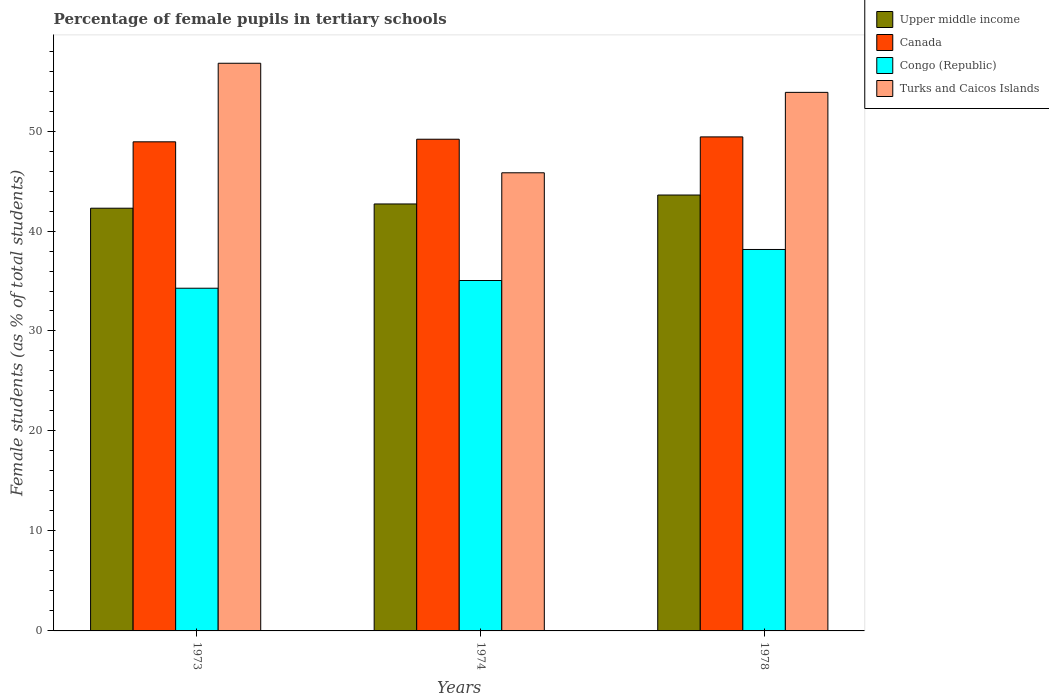How many different coloured bars are there?
Your response must be concise. 4. How many groups of bars are there?
Offer a terse response. 3. Are the number of bars on each tick of the X-axis equal?
Your response must be concise. Yes. How many bars are there on the 1st tick from the left?
Your answer should be very brief. 4. How many bars are there on the 3rd tick from the right?
Make the answer very short. 4. What is the label of the 1st group of bars from the left?
Provide a short and direct response. 1973. In how many cases, is the number of bars for a given year not equal to the number of legend labels?
Your answer should be very brief. 0. What is the percentage of female pupils in tertiary schools in Canada in 1978?
Make the answer very short. 49.41. Across all years, what is the maximum percentage of female pupils in tertiary schools in Congo (Republic)?
Give a very brief answer. 38.15. Across all years, what is the minimum percentage of female pupils in tertiary schools in Congo (Republic)?
Your answer should be compact. 34.28. In which year was the percentage of female pupils in tertiary schools in Congo (Republic) maximum?
Your answer should be compact. 1978. In which year was the percentage of female pupils in tertiary schools in Congo (Republic) minimum?
Offer a terse response. 1973. What is the total percentage of female pupils in tertiary schools in Congo (Republic) in the graph?
Provide a succinct answer. 107.48. What is the difference between the percentage of female pupils in tertiary schools in Canada in 1973 and that in 1978?
Your answer should be compact. -0.49. What is the difference between the percentage of female pupils in tertiary schools in Congo (Republic) in 1973 and the percentage of female pupils in tertiary schools in Turks and Caicos Islands in 1978?
Make the answer very short. -19.59. What is the average percentage of female pupils in tertiary schools in Turks and Caicos Islands per year?
Keep it short and to the point. 52.16. In the year 1973, what is the difference between the percentage of female pupils in tertiary schools in Upper middle income and percentage of female pupils in tertiary schools in Congo (Republic)?
Your response must be concise. 8. What is the ratio of the percentage of female pupils in tertiary schools in Turks and Caicos Islands in 1973 to that in 1978?
Offer a terse response. 1.05. What is the difference between the highest and the second highest percentage of female pupils in tertiary schools in Upper middle income?
Keep it short and to the point. 0.89. What is the difference between the highest and the lowest percentage of female pupils in tertiary schools in Turks and Caicos Islands?
Provide a short and direct response. 10.96. In how many years, is the percentage of female pupils in tertiary schools in Congo (Republic) greater than the average percentage of female pupils in tertiary schools in Congo (Republic) taken over all years?
Make the answer very short. 1. What does the 3rd bar from the left in 1973 represents?
Make the answer very short. Congo (Republic). What does the 4th bar from the right in 1978 represents?
Give a very brief answer. Upper middle income. How many bars are there?
Your answer should be compact. 12. Are all the bars in the graph horizontal?
Your response must be concise. No. What is the difference between two consecutive major ticks on the Y-axis?
Your answer should be compact. 10. Does the graph contain grids?
Your answer should be compact. No. What is the title of the graph?
Offer a very short reply. Percentage of female pupils in tertiary schools. What is the label or title of the Y-axis?
Your response must be concise. Female students (as % of total students). What is the Female students (as % of total students) of Upper middle income in 1973?
Ensure brevity in your answer.  42.28. What is the Female students (as % of total students) in Canada in 1973?
Ensure brevity in your answer.  48.92. What is the Female students (as % of total students) in Congo (Republic) in 1973?
Your answer should be very brief. 34.28. What is the Female students (as % of total students) in Turks and Caicos Islands in 1973?
Your answer should be compact. 56.78. What is the Female students (as % of total students) of Upper middle income in 1974?
Offer a terse response. 42.71. What is the Female students (as % of total students) in Canada in 1974?
Provide a succinct answer. 49.18. What is the Female students (as % of total students) of Congo (Republic) in 1974?
Your answer should be very brief. 35.05. What is the Female students (as % of total students) in Turks and Caicos Islands in 1974?
Keep it short and to the point. 45.82. What is the Female students (as % of total students) in Upper middle income in 1978?
Offer a very short reply. 43.6. What is the Female students (as % of total students) in Canada in 1978?
Offer a terse response. 49.41. What is the Female students (as % of total students) of Congo (Republic) in 1978?
Provide a succinct answer. 38.15. What is the Female students (as % of total students) of Turks and Caicos Islands in 1978?
Provide a short and direct response. 53.87. Across all years, what is the maximum Female students (as % of total students) of Upper middle income?
Your response must be concise. 43.6. Across all years, what is the maximum Female students (as % of total students) of Canada?
Give a very brief answer. 49.41. Across all years, what is the maximum Female students (as % of total students) of Congo (Republic)?
Offer a terse response. 38.15. Across all years, what is the maximum Female students (as % of total students) in Turks and Caicos Islands?
Make the answer very short. 56.78. Across all years, what is the minimum Female students (as % of total students) of Upper middle income?
Your response must be concise. 42.28. Across all years, what is the minimum Female students (as % of total students) in Canada?
Give a very brief answer. 48.92. Across all years, what is the minimum Female students (as % of total students) in Congo (Republic)?
Provide a short and direct response. 34.28. Across all years, what is the minimum Female students (as % of total students) of Turks and Caicos Islands?
Your response must be concise. 45.82. What is the total Female students (as % of total students) in Upper middle income in the graph?
Your answer should be compact. 128.59. What is the total Female students (as % of total students) of Canada in the graph?
Offer a very short reply. 147.52. What is the total Female students (as % of total students) of Congo (Republic) in the graph?
Offer a very short reply. 107.48. What is the total Female students (as % of total students) in Turks and Caicos Islands in the graph?
Provide a succinct answer. 156.47. What is the difference between the Female students (as % of total students) of Upper middle income in 1973 and that in 1974?
Make the answer very short. -0.43. What is the difference between the Female students (as % of total students) of Canada in 1973 and that in 1974?
Provide a short and direct response. -0.26. What is the difference between the Female students (as % of total students) in Congo (Republic) in 1973 and that in 1974?
Offer a terse response. -0.77. What is the difference between the Female students (as % of total students) of Turks and Caicos Islands in 1973 and that in 1974?
Give a very brief answer. 10.96. What is the difference between the Female students (as % of total students) of Upper middle income in 1973 and that in 1978?
Provide a succinct answer. -1.32. What is the difference between the Female students (as % of total students) of Canada in 1973 and that in 1978?
Provide a short and direct response. -0.49. What is the difference between the Female students (as % of total students) of Congo (Republic) in 1973 and that in 1978?
Offer a very short reply. -3.88. What is the difference between the Female students (as % of total students) of Turks and Caicos Islands in 1973 and that in 1978?
Provide a succinct answer. 2.91. What is the difference between the Female students (as % of total students) in Upper middle income in 1974 and that in 1978?
Your answer should be compact. -0.89. What is the difference between the Female students (as % of total students) of Canada in 1974 and that in 1978?
Provide a succinct answer. -0.23. What is the difference between the Female students (as % of total students) in Congo (Republic) in 1974 and that in 1978?
Your answer should be compact. -3.1. What is the difference between the Female students (as % of total students) of Turks and Caicos Islands in 1974 and that in 1978?
Provide a succinct answer. -8.04. What is the difference between the Female students (as % of total students) in Upper middle income in 1973 and the Female students (as % of total students) in Canada in 1974?
Your answer should be compact. -6.9. What is the difference between the Female students (as % of total students) in Upper middle income in 1973 and the Female students (as % of total students) in Congo (Republic) in 1974?
Make the answer very short. 7.23. What is the difference between the Female students (as % of total students) in Upper middle income in 1973 and the Female students (as % of total students) in Turks and Caicos Islands in 1974?
Provide a short and direct response. -3.54. What is the difference between the Female students (as % of total students) of Canada in 1973 and the Female students (as % of total students) of Congo (Republic) in 1974?
Your answer should be compact. 13.87. What is the difference between the Female students (as % of total students) of Canada in 1973 and the Female students (as % of total students) of Turks and Caicos Islands in 1974?
Give a very brief answer. 3.1. What is the difference between the Female students (as % of total students) of Congo (Republic) in 1973 and the Female students (as % of total students) of Turks and Caicos Islands in 1974?
Offer a very short reply. -11.55. What is the difference between the Female students (as % of total students) in Upper middle income in 1973 and the Female students (as % of total students) in Canada in 1978?
Give a very brief answer. -7.13. What is the difference between the Female students (as % of total students) of Upper middle income in 1973 and the Female students (as % of total students) of Congo (Republic) in 1978?
Offer a terse response. 4.13. What is the difference between the Female students (as % of total students) in Upper middle income in 1973 and the Female students (as % of total students) in Turks and Caicos Islands in 1978?
Make the answer very short. -11.59. What is the difference between the Female students (as % of total students) in Canada in 1973 and the Female students (as % of total students) in Congo (Republic) in 1978?
Provide a short and direct response. 10.77. What is the difference between the Female students (as % of total students) in Canada in 1973 and the Female students (as % of total students) in Turks and Caicos Islands in 1978?
Give a very brief answer. -4.95. What is the difference between the Female students (as % of total students) of Congo (Republic) in 1973 and the Female students (as % of total students) of Turks and Caicos Islands in 1978?
Give a very brief answer. -19.59. What is the difference between the Female students (as % of total students) in Upper middle income in 1974 and the Female students (as % of total students) in Canada in 1978?
Your answer should be very brief. -6.71. What is the difference between the Female students (as % of total students) in Upper middle income in 1974 and the Female students (as % of total students) in Congo (Republic) in 1978?
Make the answer very short. 4.55. What is the difference between the Female students (as % of total students) in Upper middle income in 1974 and the Female students (as % of total students) in Turks and Caicos Islands in 1978?
Your answer should be compact. -11.16. What is the difference between the Female students (as % of total students) in Canada in 1974 and the Female students (as % of total students) in Congo (Republic) in 1978?
Offer a terse response. 11.03. What is the difference between the Female students (as % of total students) in Canada in 1974 and the Female students (as % of total students) in Turks and Caicos Islands in 1978?
Your response must be concise. -4.69. What is the difference between the Female students (as % of total students) in Congo (Republic) in 1974 and the Female students (as % of total students) in Turks and Caicos Islands in 1978?
Give a very brief answer. -18.82. What is the average Female students (as % of total students) in Upper middle income per year?
Your answer should be very brief. 42.86. What is the average Female students (as % of total students) in Canada per year?
Provide a succinct answer. 49.17. What is the average Female students (as % of total students) of Congo (Republic) per year?
Your answer should be compact. 35.83. What is the average Female students (as % of total students) of Turks and Caicos Islands per year?
Ensure brevity in your answer.  52.16. In the year 1973, what is the difference between the Female students (as % of total students) in Upper middle income and Female students (as % of total students) in Canada?
Provide a short and direct response. -6.64. In the year 1973, what is the difference between the Female students (as % of total students) in Upper middle income and Female students (as % of total students) in Congo (Republic)?
Offer a terse response. 8. In the year 1973, what is the difference between the Female students (as % of total students) in Upper middle income and Female students (as % of total students) in Turks and Caicos Islands?
Your answer should be very brief. -14.5. In the year 1973, what is the difference between the Female students (as % of total students) in Canada and Female students (as % of total students) in Congo (Republic)?
Provide a succinct answer. 14.64. In the year 1973, what is the difference between the Female students (as % of total students) in Canada and Female students (as % of total students) in Turks and Caicos Islands?
Ensure brevity in your answer.  -7.86. In the year 1973, what is the difference between the Female students (as % of total students) in Congo (Republic) and Female students (as % of total students) in Turks and Caicos Islands?
Your answer should be very brief. -22.5. In the year 1974, what is the difference between the Female students (as % of total students) of Upper middle income and Female students (as % of total students) of Canada?
Your answer should be compact. -6.47. In the year 1974, what is the difference between the Female students (as % of total students) of Upper middle income and Female students (as % of total students) of Congo (Republic)?
Keep it short and to the point. 7.66. In the year 1974, what is the difference between the Female students (as % of total students) in Upper middle income and Female students (as % of total students) in Turks and Caicos Islands?
Ensure brevity in your answer.  -3.12. In the year 1974, what is the difference between the Female students (as % of total students) in Canada and Female students (as % of total students) in Congo (Republic)?
Your answer should be compact. 14.13. In the year 1974, what is the difference between the Female students (as % of total students) of Canada and Female students (as % of total students) of Turks and Caicos Islands?
Make the answer very short. 3.36. In the year 1974, what is the difference between the Female students (as % of total students) in Congo (Republic) and Female students (as % of total students) in Turks and Caicos Islands?
Your response must be concise. -10.77. In the year 1978, what is the difference between the Female students (as % of total students) of Upper middle income and Female students (as % of total students) of Canada?
Offer a very short reply. -5.81. In the year 1978, what is the difference between the Female students (as % of total students) in Upper middle income and Female students (as % of total students) in Congo (Republic)?
Provide a short and direct response. 5.45. In the year 1978, what is the difference between the Female students (as % of total students) of Upper middle income and Female students (as % of total students) of Turks and Caicos Islands?
Your response must be concise. -10.27. In the year 1978, what is the difference between the Female students (as % of total students) in Canada and Female students (as % of total students) in Congo (Republic)?
Ensure brevity in your answer.  11.26. In the year 1978, what is the difference between the Female students (as % of total students) in Canada and Female students (as % of total students) in Turks and Caicos Islands?
Provide a succinct answer. -4.45. In the year 1978, what is the difference between the Female students (as % of total students) of Congo (Republic) and Female students (as % of total students) of Turks and Caicos Islands?
Make the answer very short. -15.71. What is the ratio of the Female students (as % of total students) in Upper middle income in 1973 to that in 1974?
Your response must be concise. 0.99. What is the ratio of the Female students (as % of total students) of Congo (Republic) in 1973 to that in 1974?
Provide a short and direct response. 0.98. What is the ratio of the Female students (as % of total students) of Turks and Caicos Islands in 1973 to that in 1974?
Provide a succinct answer. 1.24. What is the ratio of the Female students (as % of total students) in Upper middle income in 1973 to that in 1978?
Your response must be concise. 0.97. What is the ratio of the Female students (as % of total students) of Congo (Republic) in 1973 to that in 1978?
Give a very brief answer. 0.9. What is the ratio of the Female students (as % of total students) in Turks and Caicos Islands in 1973 to that in 1978?
Ensure brevity in your answer.  1.05. What is the ratio of the Female students (as % of total students) in Upper middle income in 1974 to that in 1978?
Offer a terse response. 0.98. What is the ratio of the Female students (as % of total students) in Canada in 1974 to that in 1978?
Ensure brevity in your answer.  1. What is the ratio of the Female students (as % of total students) in Congo (Republic) in 1974 to that in 1978?
Your answer should be compact. 0.92. What is the ratio of the Female students (as % of total students) in Turks and Caicos Islands in 1974 to that in 1978?
Your answer should be compact. 0.85. What is the difference between the highest and the second highest Female students (as % of total students) in Upper middle income?
Provide a short and direct response. 0.89. What is the difference between the highest and the second highest Female students (as % of total students) in Canada?
Your response must be concise. 0.23. What is the difference between the highest and the second highest Female students (as % of total students) of Congo (Republic)?
Provide a short and direct response. 3.1. What is the difference between the highest and the second highest Female students (as % of total students) in Turks and Caicos Islands?
Provide a succinct answer. 2.91. What is the difference between the highest and the lowest Female students (as % of total students) in Upper middle income?
Give a very brief answer. 1.32. What is the difference between the highest and the lowest Female students (as % of total students) in Canada?
Your answer should be very brief. 0.49. What is the difference between the highest and the lowest Female students (as % of total students) of Congo (Republic)?
Give a very brief answer. 3.88. What is the difference between the highest and the lowest Female students (as % of total students) in Turks and Caicos Islands?
Provide a short and direct response. 10.96. 